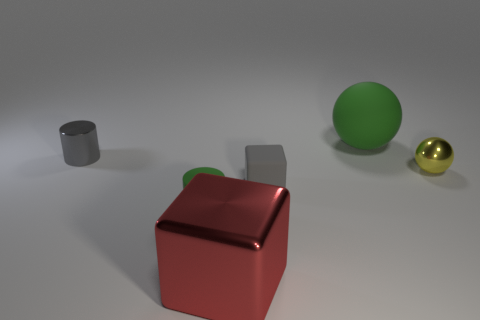Add 1 big metallic cylinders. How many objects exist? 7 Subtract all blocks. How many objects are left? 4 Subtract 0 yellow cylinders. How many objects are left? 6 Subtract all tiny shiny cylinders. Subtract all tiny gray objects. How many objects are left? 3 Add 6 big matte balls. How many big matte balls are left? 7 Add 3 yellow spheres. How many yellow spheres exist? 4 